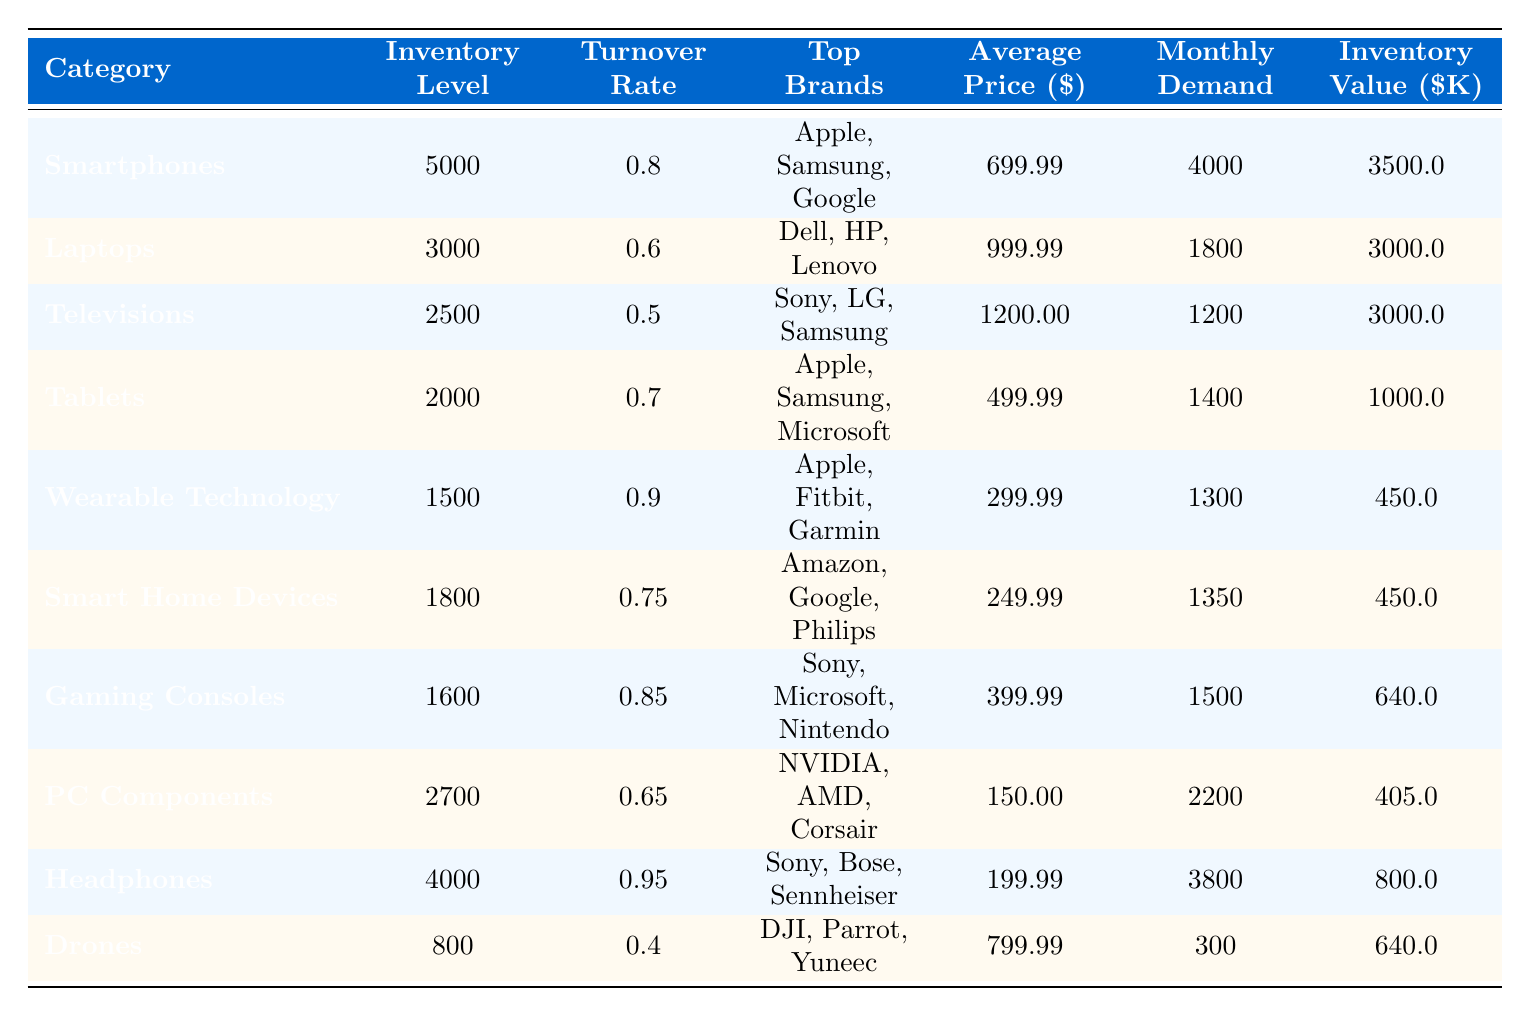What is the inventory level for Smartphones? The table shows that the inventory level for Smartphones is listed directly in the corresponding row, which is 5000 units.
Answer: 5000 Which category has the highest turnover rate? By examining the turnover rates in the table, the Wearable Technology category has the highest turnover rate at 0.9.
Answer: Wearable Technology What is the average price of Gaming Consoles? The average price for Gaming Consoles is given in the table, specifically in its row, which is $399.99.
Answer: 399.99 How many units of Tablets are available compared to the monthly demand? The inventory level for Tablets is 2000, while the monthly demand is 1400. Comparing these values shows the inventory level exceeds monthly demand by 600 units.
Answer: 600 Which category has the lowest monthly demand, and what is that demand? From the table, Drones has the lowest monthly demand at 300 units.
Answer: 300 What is the total inventory value for Laptops? The inventory value is calculated by multiplying the inventory level (3000 units) by the average price ($999.99), resulting in an inventory value of $3000.00K.
Answer: 3000.0 Are there more Headphones available than Drones? The inventory level of Headphones is 4000 while Drones only has 800, indicating there are significantly more Headphones available.
Answer: Yes Calculate the total inventory levels for both Smart Home Devices and Drones. The inventory levels for Smart Home Devices and Drones are 1800 and 800, respectively. Adding these gives a total of 2600 units.
Answer: 2600 What percentage of the monthly demand for Smartphones is covered by the current inventory level? The monthly demand for Smartphones is 4000 units, and the inventory level is 5000. To find the percentage covered, divide the inventory level by monthly demand (5000/4000) and multiply by 100, resulting in 125%.
Answer: 125% Is the average price of Televisions higher than that of Tablets? The average price of Televisions is $1200.00, while Tablets are priced at $499.99. Since $1200.00 is greater than $499.99, the assertion is true.
Answer: Yes If you sum the turnover rates of all categories, what is the total? Adding the turnover rates from the table gives 0.8 + 0.6 + 0.5 + 0.7 + 0.9 + 0.75 + 0.85 + 0.65 + 0.95 + 0.4 = 6.15.
Answer: 6.15 